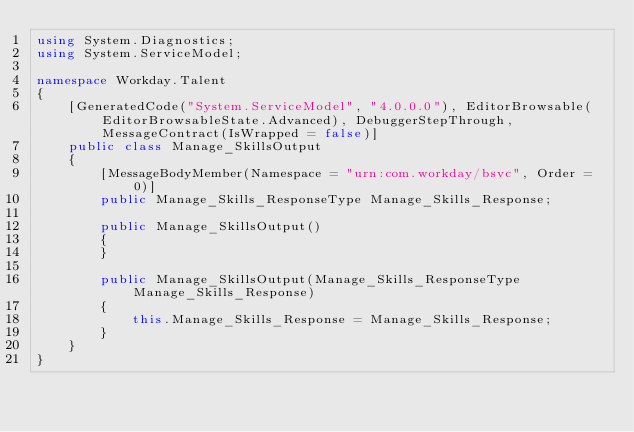Convert code to text. <code><loc_0><loc_0><loc_500><loc_500><_C#_>using System.Diagnostics;
using System.ServiceModel;

namespace Workday.Talent
{
	[GeneratedCode("System.ServiceModel", "4.0.0.0"), EditorBrowsable(EditorBrowsableState.Advanced), DebuggerStepThrough, MessageContract(IsWrapped = false)]
	public class Manage_SkillsOutput
	{
		[MessageBodyMember(Namespace = "urn:com.workday/bsvc", Order = 0)]
		public Manage_Skills_ResponseType Manage_Skills_Response;

		public Manage_SkillsOutput()
		{
		}

		public Manage_SkillsOutput(Manage_Skills_ResponseType Manage_Skills_Response)
		{
			this.Manage_Skills_Response = Manage_Skills_Response;
		}
	}
}
</code> 